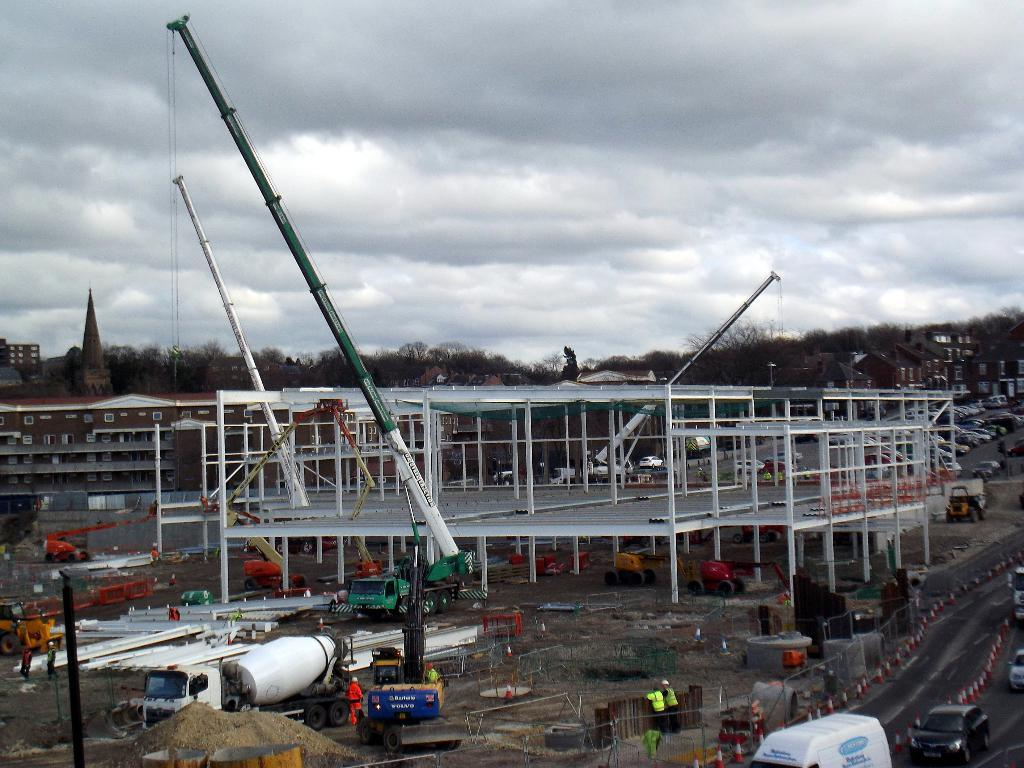What type of structures can be seen in the image? There are buildings in the image. What natural elements are present in the image? There are trees in the image. What man-made objects can be seen in the image? There are vehicles in the image. Are there any living beings in the image? Yes, there are people in the image. What additional objects can be seen in the image? There are poles and other objects in the image. What can be seen in the background of the image? The sky is visible in the background of the image. What type of banana is hanging from the pole in the image? There is no banana present in the image; it features buildings, trees, vehicles, people, poles, and other objects. Can you describe the locket worn by the person in the image? There is no locket visible on any person in the image. 